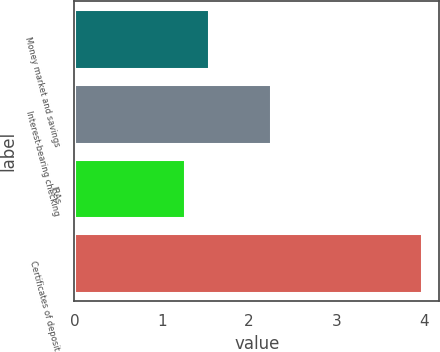<chart> <loc_0><loc_0><loc_500><loc_500><bar_chart><fcel>Money market and savings<fcel>Interest-bearing checking<fcel>IRAs<fcel>Certificates of deposit<nl><fcel>1.54<fcel>2.25<fcel>1.27<fcel>3.98<nl></chart> 